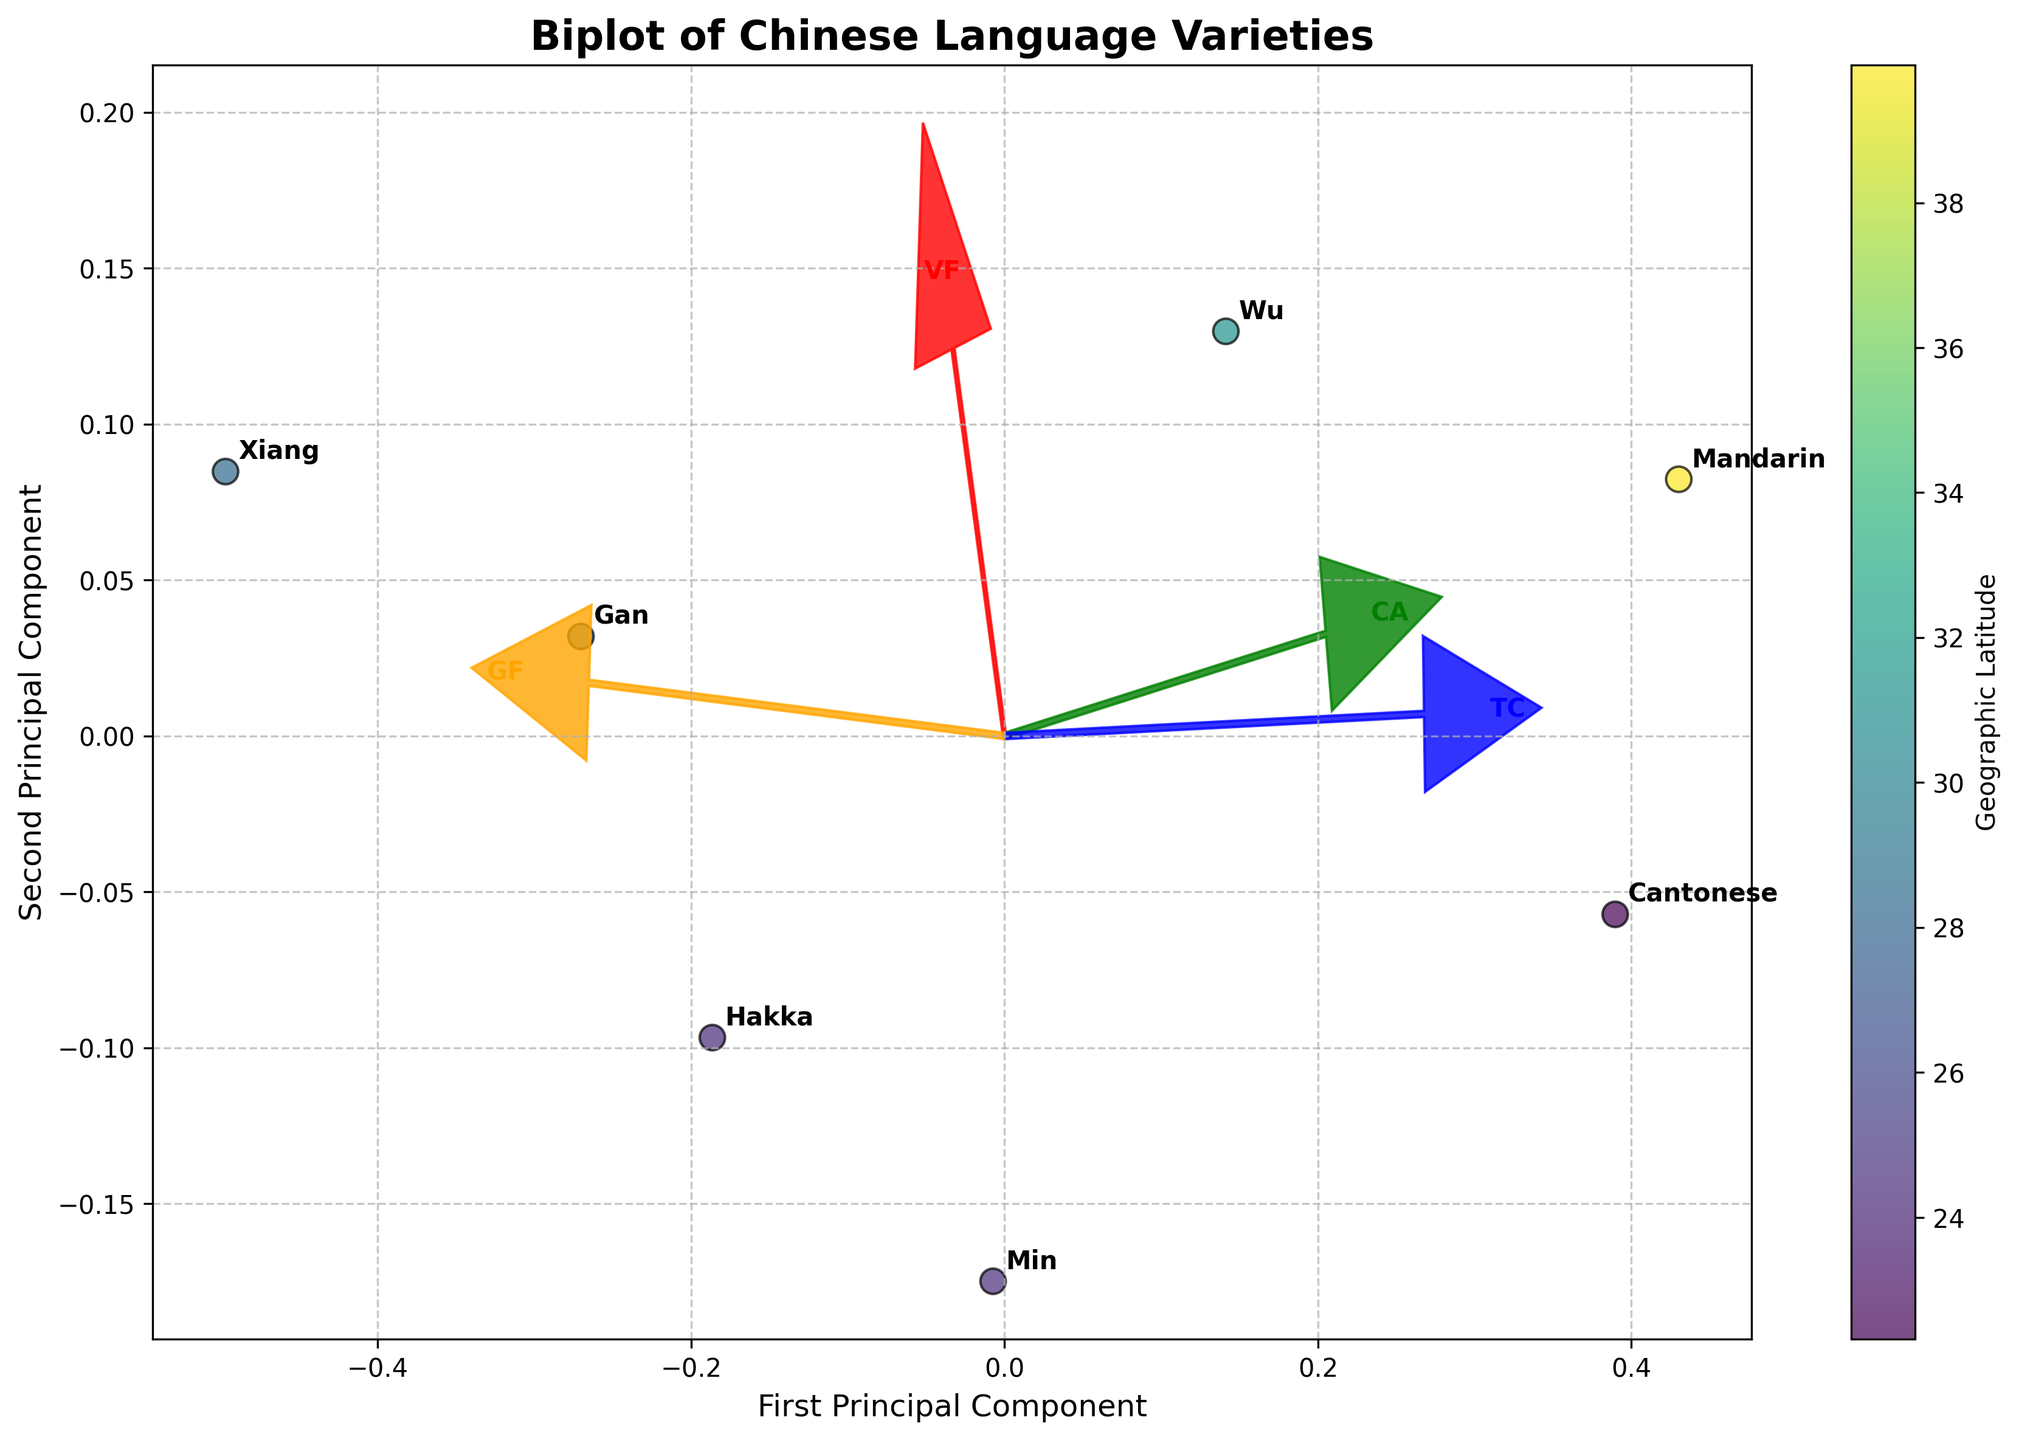How many accents are represented in the biplot and how do we know that? Count the number of unique annotations on the plot. Each annotation represents a different accent.
Answer: 7 What is the title of the figure? Look at the top of the figure where the title text is located.
Answer: Biplot of Chinese Language Varieties Which language has the highest value for the first principal component? Identify the points on the first principal component axis and check the annotation that corresponds to the highest value.
Answer: Wu (indicated by "Shanghai") Which language is closest to the origin (0,0) in the plot? Find the point that is nearest to the intersection of the x-axis and y-axis.
Answer: Mandarin (indicated by "Beijing") Which feature vector has the largest projection on the first principal component axis? Look for the arrow that extends the farthest along the direction of the first principal component.
Answer: VowelFrontness (VF) What is the geographical latitude of the language closest to the top right on the plot? Identify the point closest to the top right and refer to its geographical latitude from the colorbar.
Answer: Mandarin (39.9042) Are tonal complexity and glottalization frequency more strongly correlated with the first or the second principal component? Check the projection length of the arrows for TonalComplexity (TC) and GlottalizationFrequency (GF) on each principal component axis.
Answer: Second principal component Which language has the lowest value along the vertical (second principal component) axis? Identify the point with the lowest value on the vertical axis and note the corresponding language annotation.
Answer: Xiang (indicated by "Changsha") Which regions have languages located on the positive side of both principal components? Look at the points in the first quadrant (both principal components are positive) and identify the regions.
Answer: Beijing and Shanghai What does the color of the data points represent and how can we determine this? Refer to the colorbar on the plot to understand what the colors indicate.
Answer: Geographic Latitude 